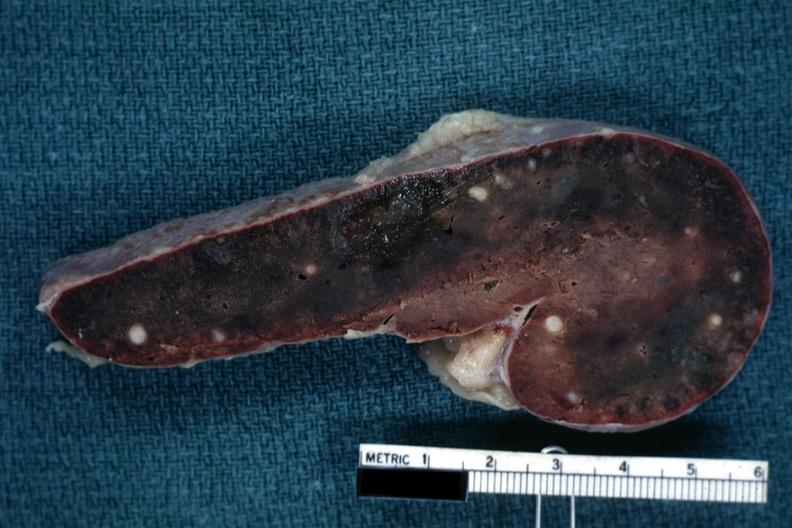s hematologic present?
Answer the question using a single word or phrase. Yes 